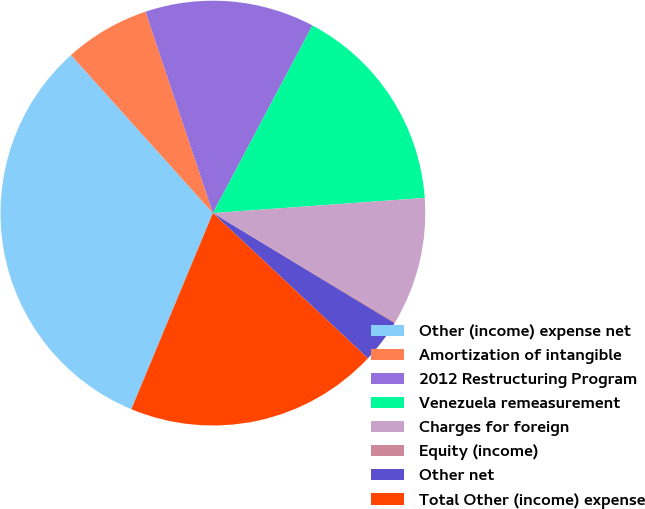Convert chart. <chart><loc_0><loc_0><loc_500><loc_500><pie_chart><fcel>Other (income) expense net<fcel>Amortization of intangible<fcel>2012 Restructuring Program<fcel>Venezuela remeasurement<fcel>Charges for foreign<fcel>Equity (income)<fcel>Other net<fcel>Total Other (income) expense<nl><fcel>32.08%<fcel>6.51%<fcel>12.9%<fcel>16.1%<fcel>9.7%<fcel>0.11%<fcel>3.31%<fcel>19.29%<nl></chart> 